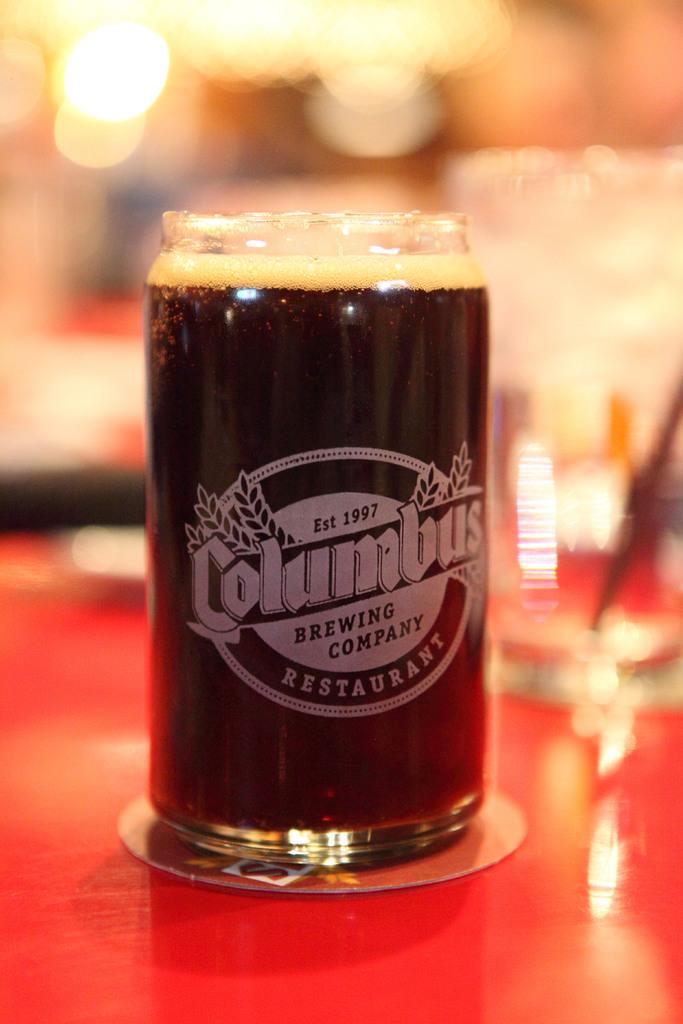Where did they serve this drink?
Offer a terse response. Columbus. What year was the columbus brewing company established?
Keep it short and to the point. 1997. 